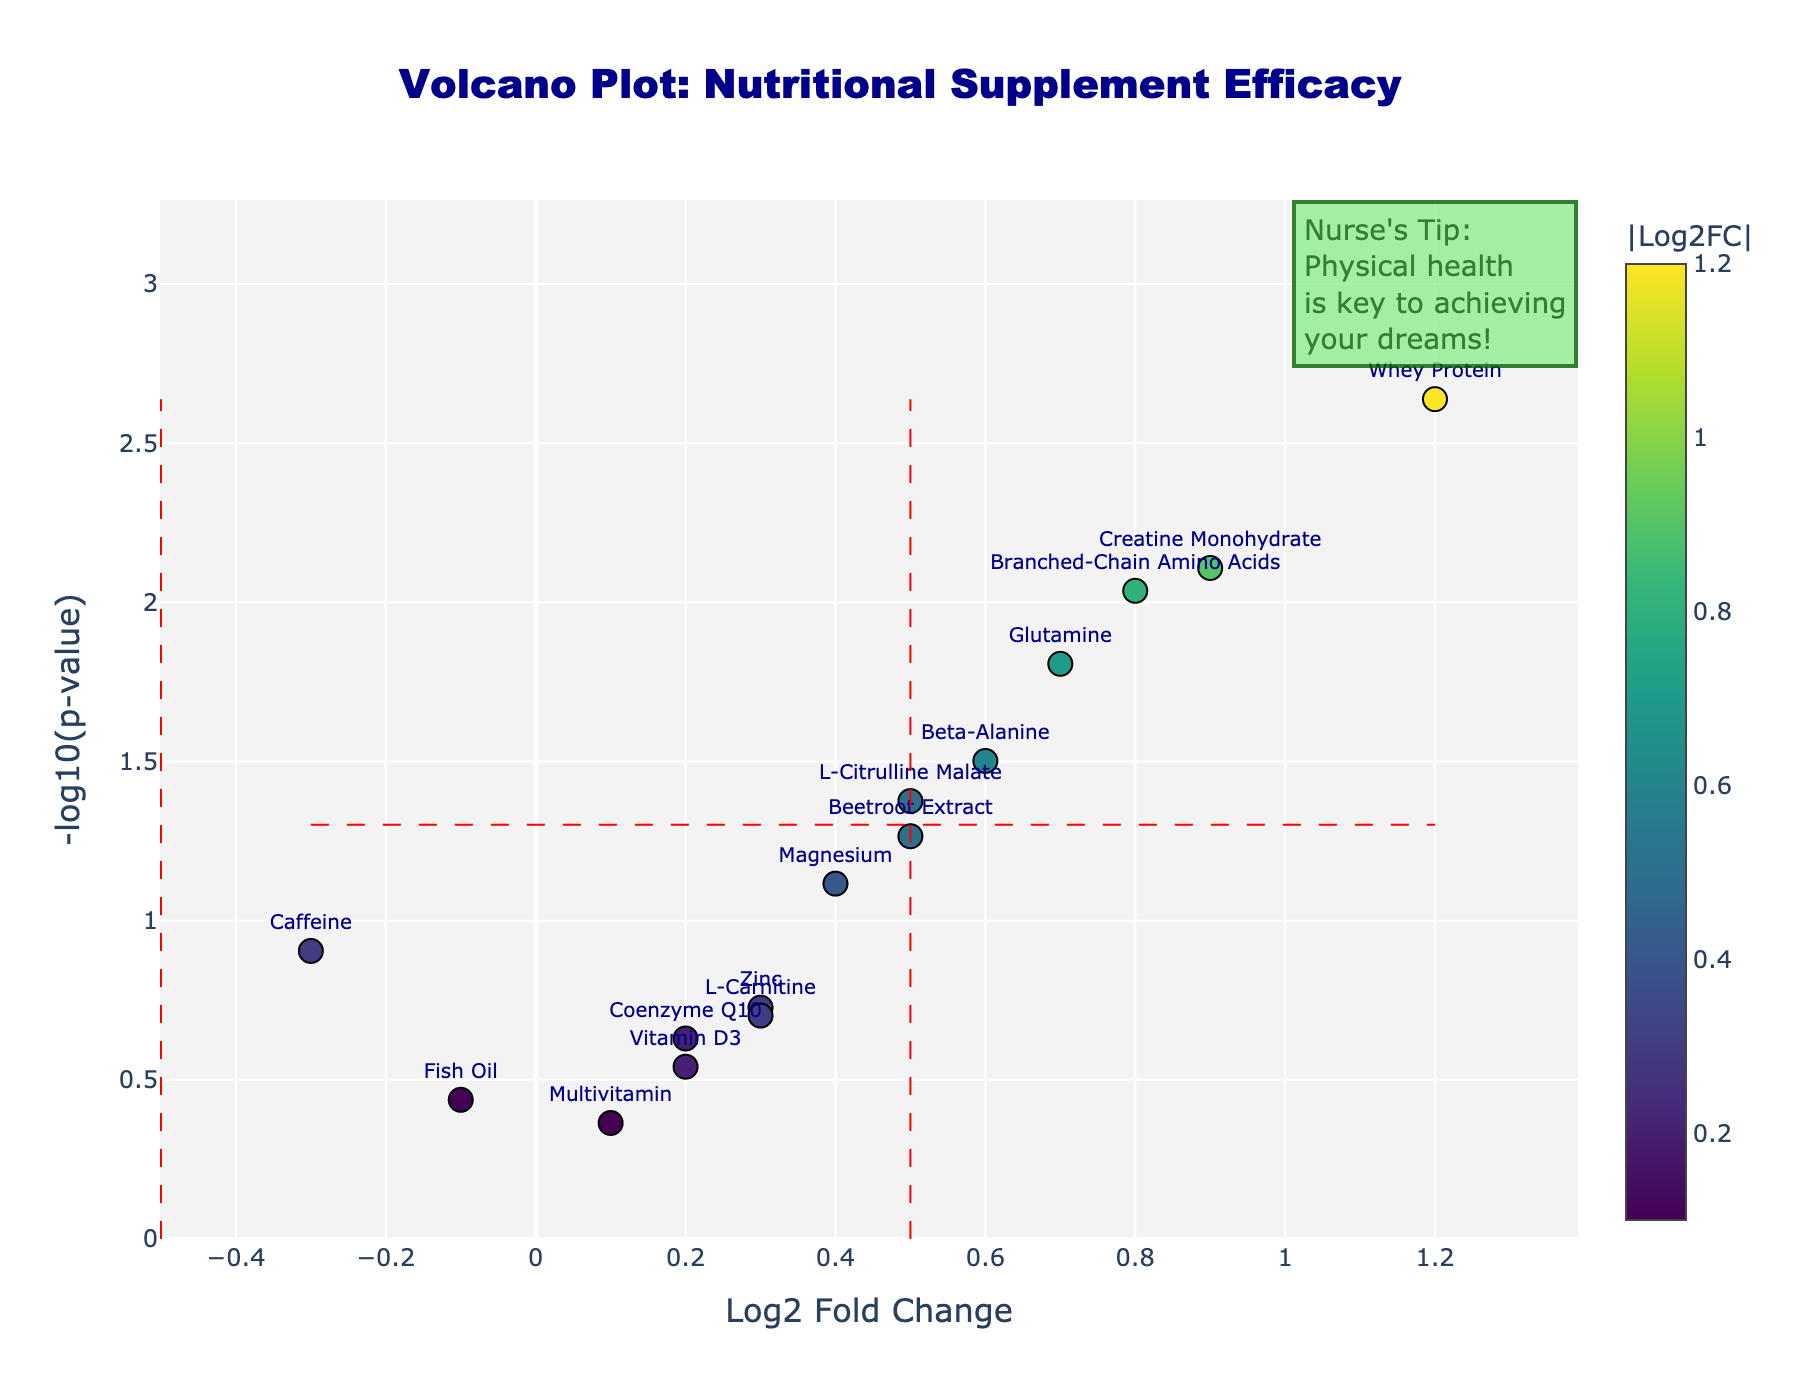Which supplement has the highest log2 fold change? The highest log2 fold change can be found by identifying the data point that is furthest to the right on the x-axis of the plot. In this case, "Whey Protein" is the furthest to the right.
Answer: Whey Protein What is the log2 fold change and p-value of Beta-Alanine? The log2 fold change and p-value for Beta-Alanine can be found by locating its label on the plot. The hover text displays them as approximately 0.6 for log2 fold change and 0.0315 for p-value.
Answer: 0.6 and 0.0315 Which supplements have a statistically significant effect based on p-value ≤ 0.05? Supplements with significant effects are those above the horizontal threshold line (indicating p-value ≤ 0.05). These are Whey Protein, Creatine Monohydrate, Beta-Alanine, Branched-Chain Amino Acids, Glutamine, and L-Citrulline Malate.
Answer: Whey Protein, Creatine Monohydrate, Beta-Alanine, Branched-Chain Amino Acids, Glutamine, L-Citrulline Malate Which supplement has the lowest p-value? The supplement with the highest y-axis value (indicating the lowest p-value) is "Whey Protein".
Answer: Whey Protein How many supplements have a log2 fold change greater than 0.5? By counting the data points to the right of the vertical threshold line at 0.5 on the x-axis, the supplements are Whey Protein, Creatine Monohydrate, Branched-Chain Amino Acids, and Glutamine, making a total of four.
Answer: Four Which supplement is most downregulated according to the log2 fold change? The most downregulated supplement should be furthest to the left on the x-axis. "Caffeine" has the most negative log2 fold change at -0.3.
Answer: Caffeine How does the significance of Vitamin D3 compare to that of Fish Oil? To compare, look at the y-axis positions for both Vitamin D3 and Fish Oil. Vitamin D3 is higher, meaning it has a lower p-value (more significant) than Fish Oil.
Answer: Vitamin D3 is more significant What is the log2 fold change range for supplements with non-significant effects (p-value > 0.05)? The non-significant supplements are located below the horizontal threshold line (p-value > 0.05). Their log2 fold changes range from -0.3 (Caffeine) to 0.4 (Magnesium).
Answer: -0.3 to 0.4 What additional insight could be drawn from the placement of data points within quadrants defined by threshold lines? The quadrants can show combinations of high/low efficacy and significance. For example, Whey Protein is in the top-right quadrant indicating high efficacy and high significance, whereas Caffeine in the bottom-left shows low efficacy and low significance.
Answer: Diverse insights 